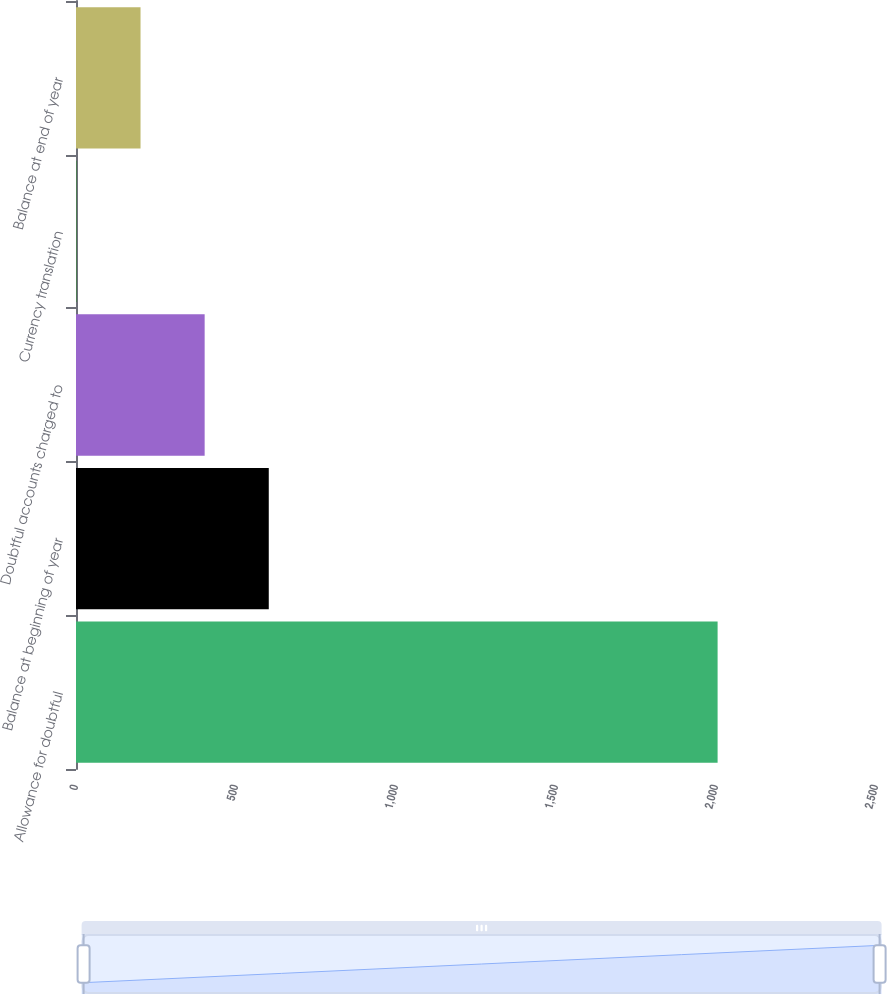<chart> <loc_0><loc_0><loc_500><loc_500><bar_chart><fcel>Allowance for doubtful<fcel>Balance at beginning of year<fcel>Doubtful accounts charged to<fcel>Currency translation<fcel>Balance at end of year<nl><fcel>2005<fcel>602.41<fcel>402.04<fcel>1.3<fcel>201.67<nl></chart> 